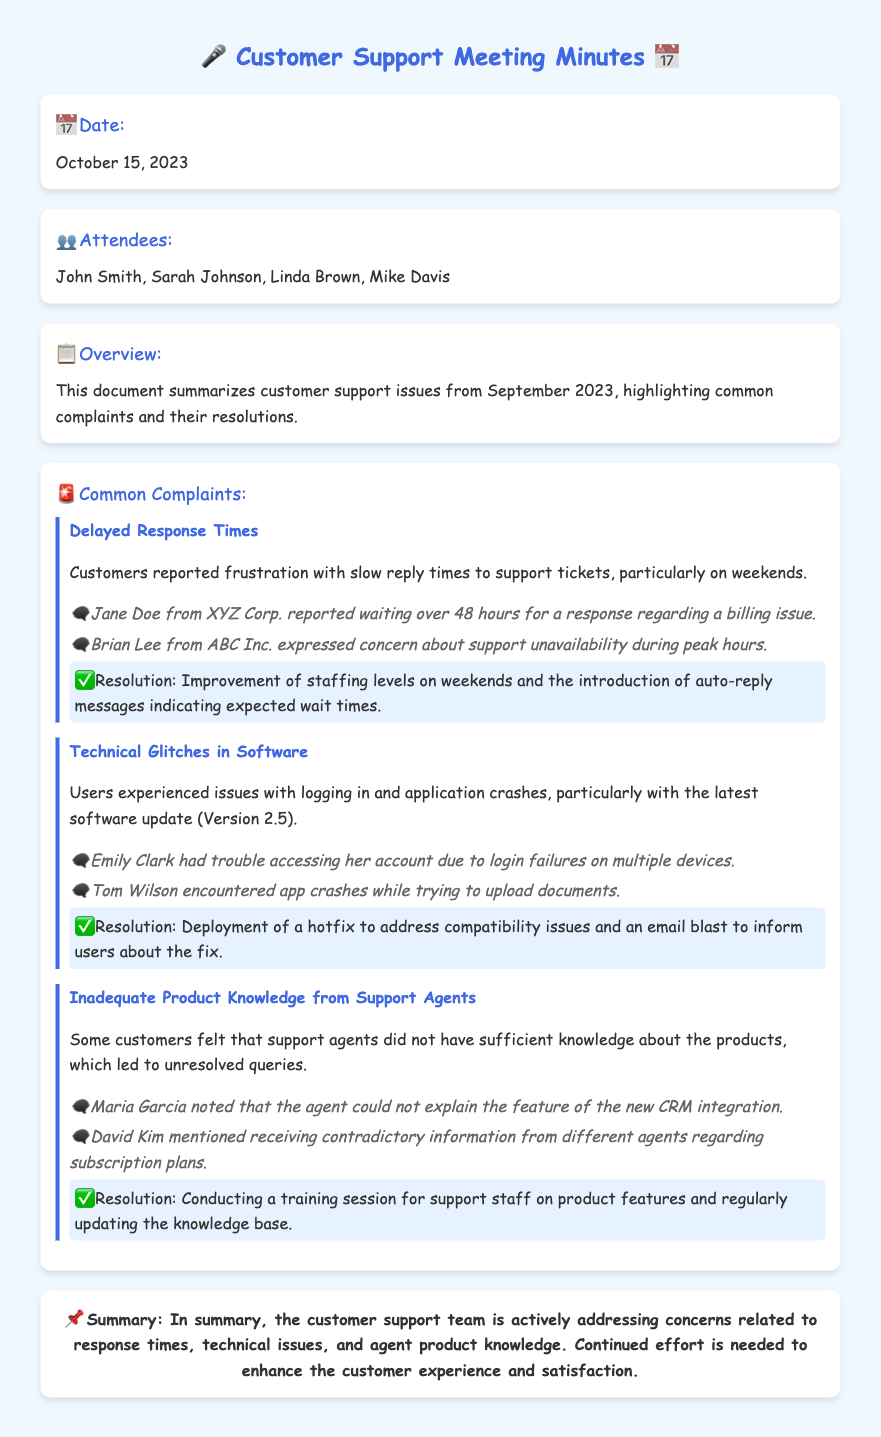What is the date of the meeting? The date is mentioned in the overview section of the document.
Answer: October 15, 2023 Who reported issues related to delayed response times? The document lists specific customers who reported complaints, including their names.
Answer: Jane Doe What technical issue was associated with software update version 2.5? The document specifies the nature of the complaints related to the software update.
Answer: Login failures and application crashes What resolution was proposed for inadequate product knowledge from support agents? The resolution section discusses how to improve support knowledge.
Answer: Conducting a training session How many attendees were present at the meeting? The attendees' names are listed towards the beginning of the document.
Answer: Four What emotion did Brian Lee express in his complaint? His specific complaint is detailed in the document.
Answer: Concern What is the summary point of the customer support issues? The summary section encapsulates the overall situation addressed in the document.
Answer: Actively addressing concerns What did Mike Davis do during the meeting? The document lists the attendees but does not specify actions taken.
Answer: Not specified 